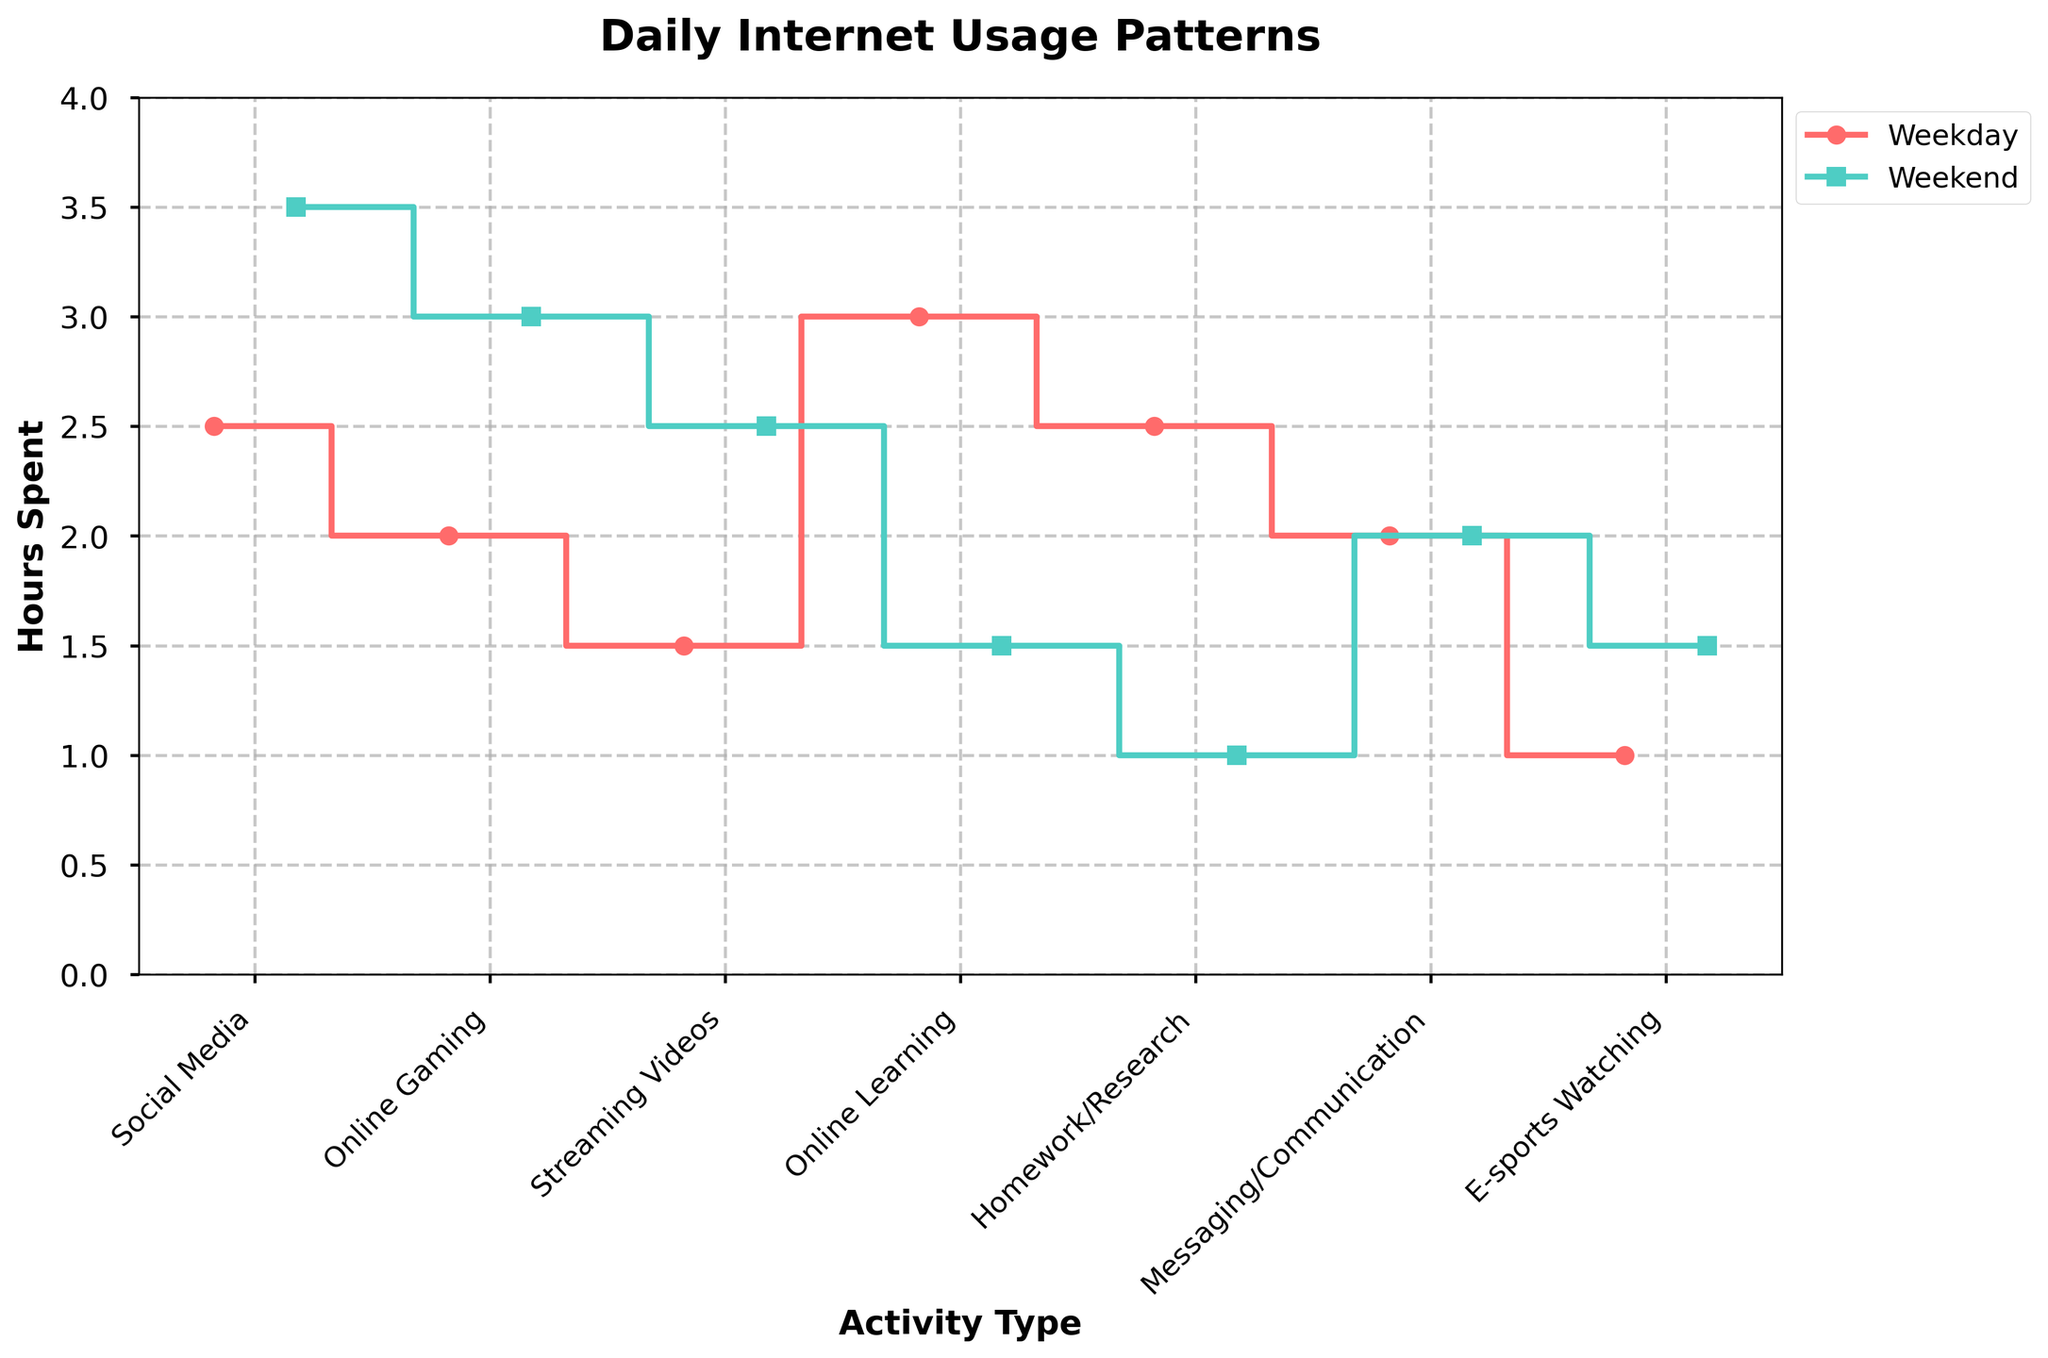What are the colors representing weekdays and weekends in the figure? The weekdays are represented by a red line and the weekends are represented by a green line, easily identifiable by their distinct colors and labels in the legend.
Answer: Red for weekdays and green for weekends Which activity has the highest internet usage on weekdays? To determine the activity with the highest usage on weekdays, look at the highest point on the red line in the stair plot. The activity at this point is 'Online Learning'.
Answer: Online Learning What's the difference in internet usage for homework/research between weekdays and weekends? Identify the usage for 'Homework/Research' on both the weekday and weekend lines. For weekdays it's 2.5 hours and for weekends it's 1 hour. The difference is 2.5 - 1 = 1.5 hours.
Answer: 1.5 hours Which activity has the smallest difference in hours spent between weekdays and weekends? Compare the differences between weekday and weekend hours for all activities. Several activities (Messaging/Communication, E-sports Watching, and Online Gaming) show only a small difference, but the smallest is for Messaging/Communication.
Answer: Messaging/Communication How does the usage of social media change from weekdays to weekends? Observe the points for 'Social Media' usage in the stair plot. It shows an increase from 2.5 hours on weekdays to 3.5 hours on weekends.
Answer: It increases What is the total internet usage on weekdays and weekends for streaming videos? Summarize the hours of streaming videos for both weekdays (1.5) and weekends (2.5). Adding these gives 4 hours.
Answer: 4 hours Which activity sees a decrease in usage from weekdays to weekends? Look for activities where the weekend point is lower than the weekday point. 'Online Learning' and 'Homework/Research' show decreases.
Answer: Online Learning and Homework/Research What is the average internet usage time across all activities on weekdays? Sum the weekday hours for all activities (2.5+2+1.5+3+2.5+2+1=14.5) and divide it by the number of activities (7). The average is 14.5/7 ≈ 2.07 hours.
Answer: 2.07 hours Which has a greater difference between weekday and weekend usage: social media or online gaming? Calculate the differences: For social media (3.5 - 2.5 = 1 hour) and for online gaming (3 - 2 = 1 hour). Both have the same difference.
Answer: They have the same difference How much more time is spent on messaging/communication during weekdays compared to watching esports on weekends? Identify the hours: messaging/communication on weekdays (2 hours) and esports on weekends (1.5 hours). The difference is 2 - 1.5 = 0.5 hours.
Answer: 0.5 hours 